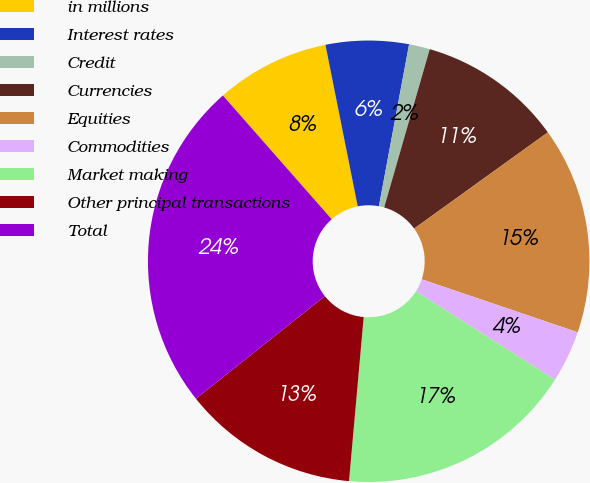<chart> <loc_0><loc_0><loc_500><loc_500><pie_chart><fcel>in millions<fcel>Interest rates<fcel>Credit<fcel>Currencies<fcel>Equities<fcel>Commodities<fcel>Market making<fcel>Other principal transactions<fcel>Total<nl><fcel>8.34%<fcel>6.07%<fcel>1.53%<fcel>10.61%<fcel>15.14%<fcel>3.8%<fcel>17.41%<fcel>12.88%<fcel>24.22%<nl></chart> 